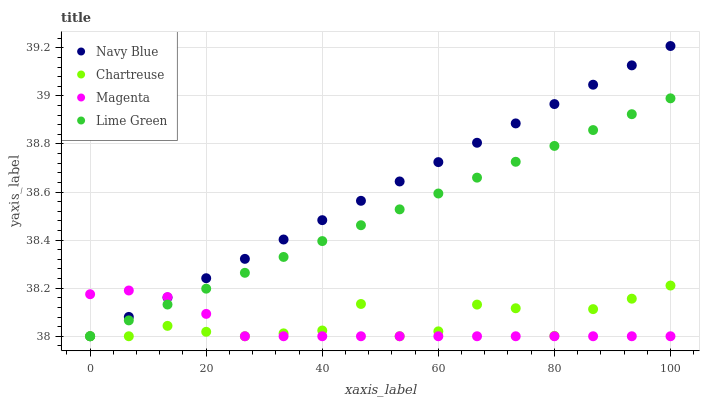Does Magenta have the minimum area under the curve?
Answer yes or no. Yes. Does Navy Blue have the maximum area under the curve?
Answer yes or no. Yes. Does Chartreuse have the minimum area under the curve?
Answer yes or no. No. Does Chartreuse have the maximum area under the curve?
Answer yes or no. No. Is Navy Blue the smoothest?
Answer yes or no. Yes. Is Chartreuse the roughest?
Answer yes or no. Yes. Is Lime Green the smoothest?
Answer yes or no. No. Is Lime Green the roughest?
Answer yes or no. No. Does Navy Blue have the lowest value?
Answer yes or no. Yes. Does Navy Blue have the highest value?
Answer yes or no. Yes. Does Chartreuse have the highest value?
Answer yes or no. No. Does Navy Blue intersect Magenta?
Answer yes or no. Yes. Is Navy Blue less than Magenta?
Answer yes or no. No. Is Navy Blue greater than Magenta?
Answer yes or no. No. 